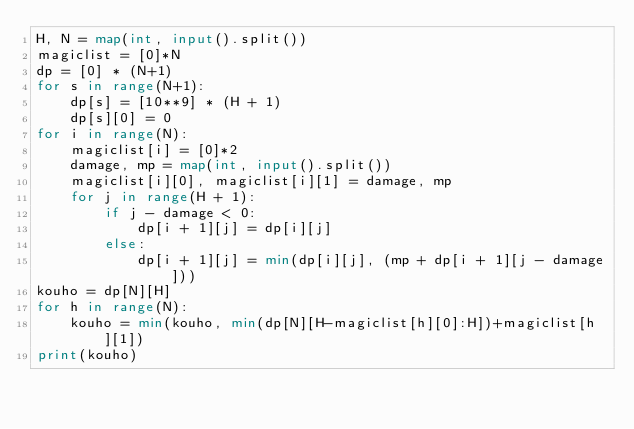Convert code to text. <code><loc_0><loc_0><loc_500><loc_500><_Python_>H, N = map(int, input().split())
magiclist = [0]*N
dp = [0] * (N+1)
for s in range(N+1):
    dp[s] = [10**9] * (H + 1)
    dp[s][0] = 0
for i in range(N):
    magiclist[i] = [0]*2
    damage, mp = map(int, input().split())
    magiclist[i][0], magiclist[i][1] = damage, mp
    for j in range(H + 1):
        if j - damage < 0:
            dp[i + 1][j] = dp[i][j]
        else:
            dp[i + 1][j] = min(dp[i][j], (mp + dp[i + 1][j - damage]))
kouho = dp[N][H]
for h in range(N):
    kouho = min(kouho, min(dp[N][H-magiclist[h][0]:H])+magiclist[h][1])
print(kouho)
</code> 